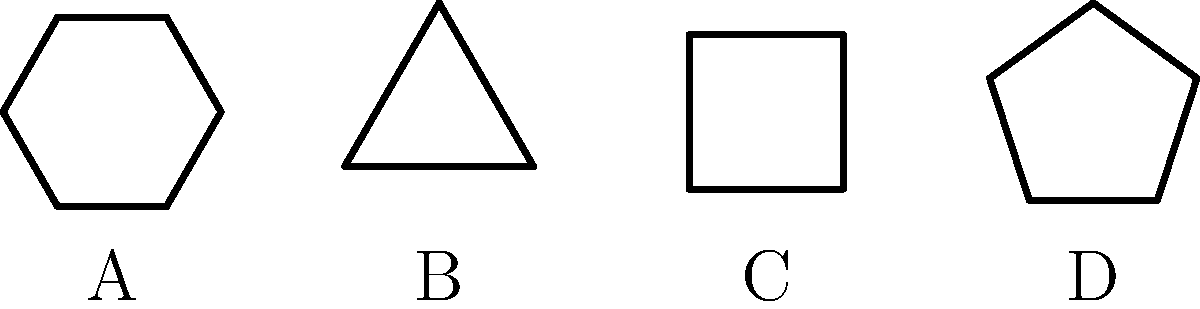Which of the folded shapes (B, C, or D) represents the correct fold pattern for the compact tent design shown in shape A? To determine the correct fold pattern, we need to analyze the geometric properties of each shape:

1. Shape A (original tent): Hexagon with 6 sides
2. Shape B: Triangle with 3 sides
3. Shape C: Square with 4 sides
4. Shape D: Pentagon with 5 sides

Step 1: Consider the number of sides in the original shape (A) and the folded shapes.
- The original shape has 6 sides.
- The folded shape should have fewer sides than the original.

Step 2: Analyze the folding process:
- Folding a hexagon typically involves reducing the number of visible sides.
- The most efficient fold would reduce the number of sides while maintaining a compact shape.

Step 3: Evaluate each option:
- Shape B (triangle): Too few sides, would require excessive folding and may not be stable.
- Shape C (square): A reasonable reduction in sides, maintains stability and compactness.
- Shape D (pentagon): Only reduces the sides by one, not as compact as possible.

Step 4: Consider practical aspects of tent design:
- A square base is common in compact tent designs.
- It provides a good balance between stability and portability.

Conclusion: Shape C (square) is the most likely correct fold pattern for the compact tent design.
Answer: C 